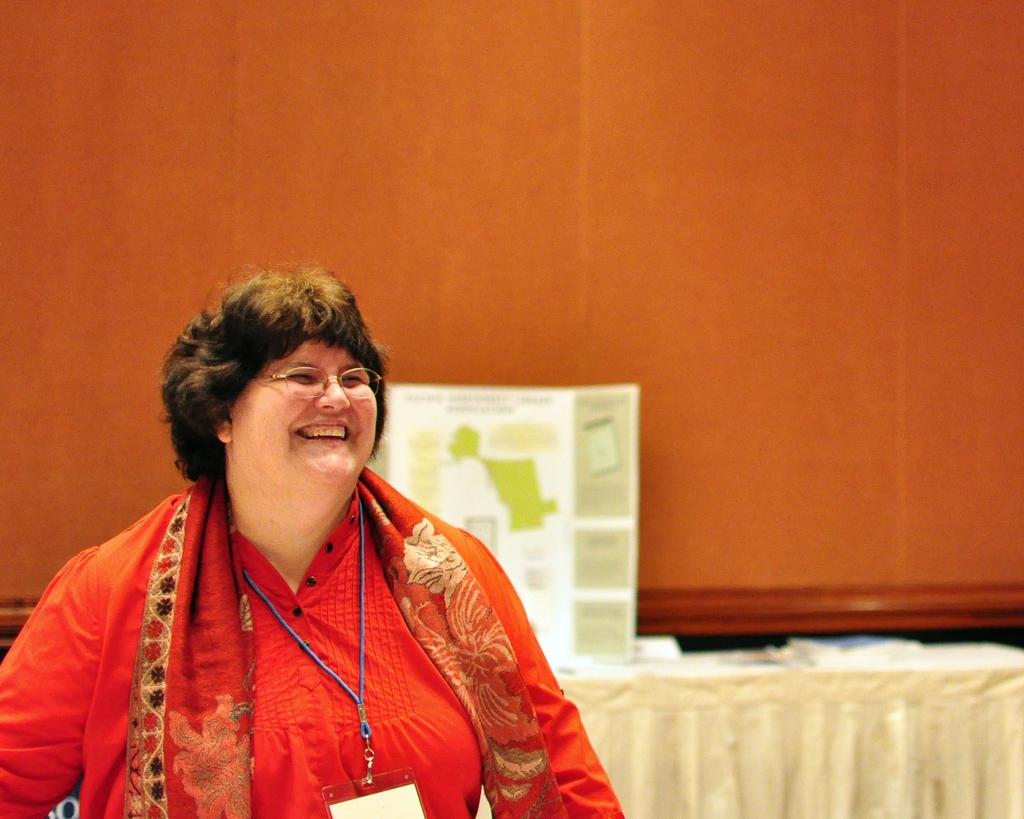Who is present in the image? There is a woman in the image. What is the woman's expression? The woman is smiling. What can be seen in the background of the image? There is a poster in the background of the image. What is on the table in the image? There is a table with a cloth in the image, and there are objects on the table. Can you see any blood on the woman's clothes in the image? No, there is no blood visible on the woman's clothes in the image. Is there a ship in the image? No, there is no ship present in the image. 